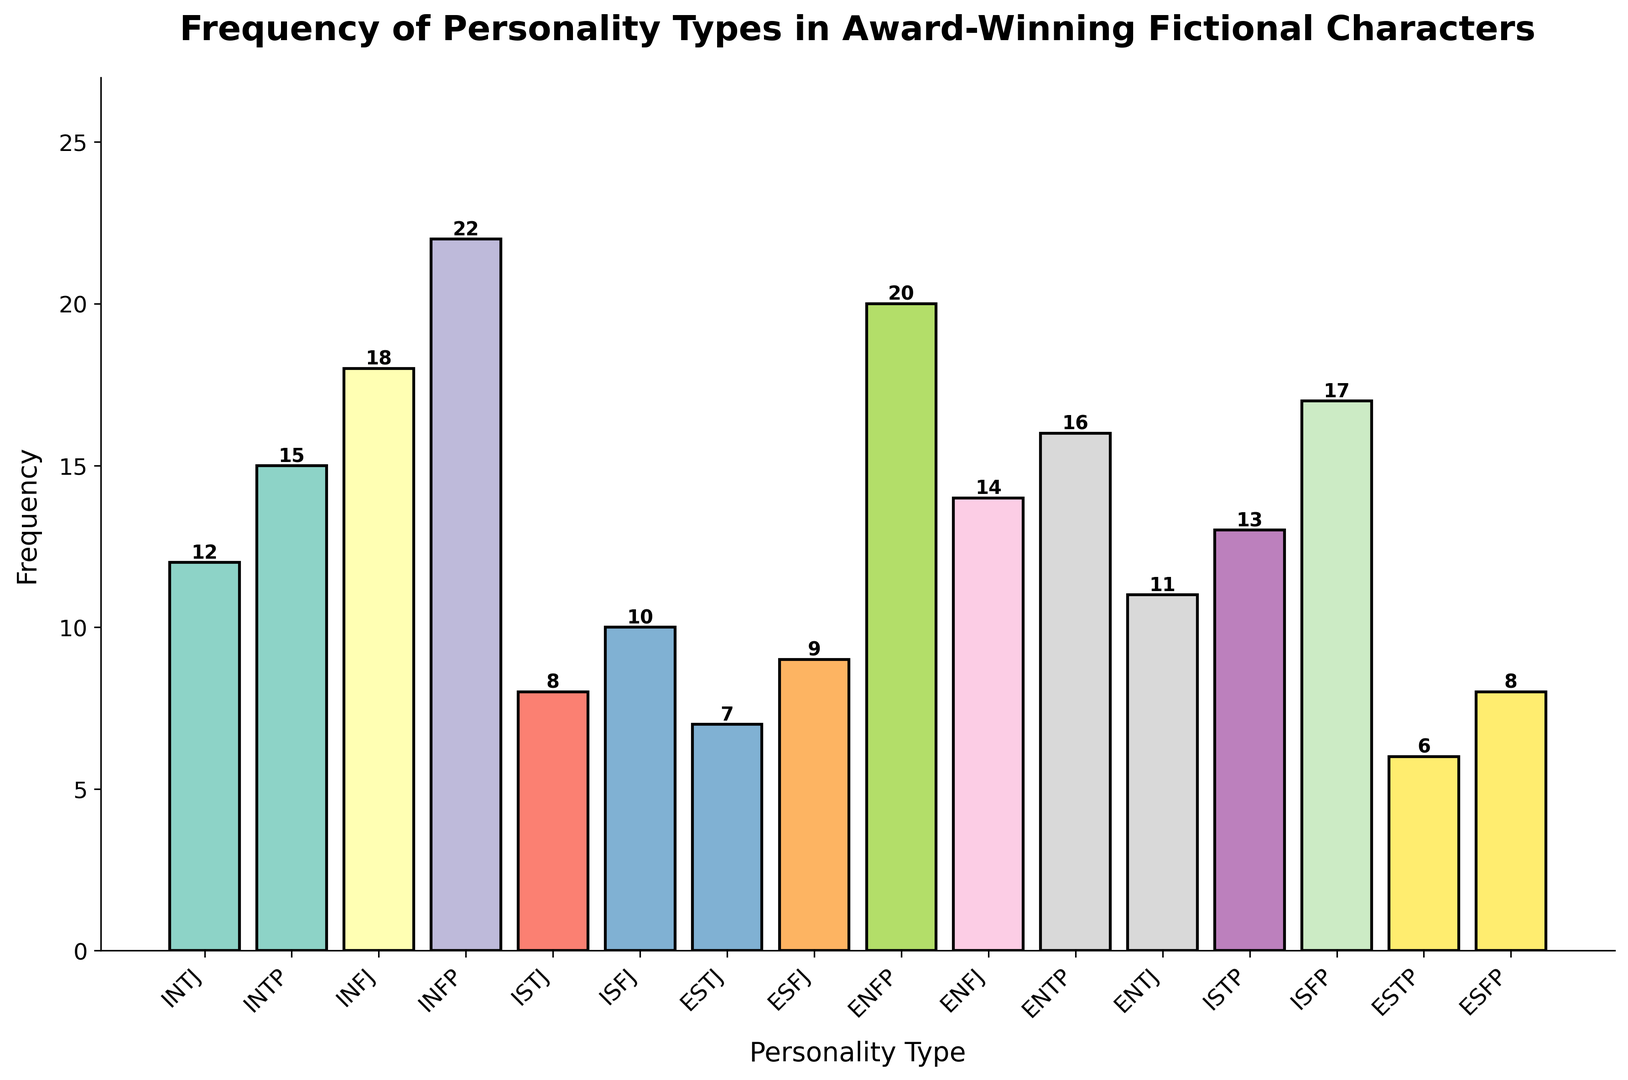What personality type has the highest frequency? We identify the highest bar in the histogram, which represents the INFP personality type with a frequency of 22.
Answer: INFP Which personality type has the lowest frequency? We look for the shortest bar in the histogram, which is ESTP with a frequency of 6.
Answer: ESTP What is the total frequency of INFJ and INFP personality types? Find the frequencies of INFJ and INFP (18 and 22 respectively) and sum them up (18 + 22 = 40).
Answer: 40 How many personality types have a frequency of 10 or more? Count the bars that have a frequency of 10 or more: INTP (15), INFJ (18), INFP (22), ISFJ (10), ENFP (20), ENFJ (14), ENTP (16), ENTJ (11), ISTP (13), ISFP (17). There are 10 personality types.
Answer: 10 Which personality type has a frequency closest to the average frequency? First, calculate the average frequency by summing all frequencies (210) and dividing by the number of personality types (16), which is 210 / 16 = 13.125. The closest frequency to 13.125 is that of ISTP, which is 13.
Answer: ISTP What is the frequency difference between the most and least frequent personality types? Subtract the frequency of the least frequent (ESTP, 6) from the most frequent (INFP, 22) to find the difference (22 - 6 = 16).
Answer: 16 How many personality types have frequencies between 10 and 20? Count the bars that fall between 10 and 20: INTP (15), INFJ (18), ISFJ (10), ENFP (20), ENFJ (14), ENTP (16), ENTJ (11), ISTP (13), ISFP (17), which total 9 bars.
Answer: 9 Which personality type has the third highest frequency? After INFP (22) and ENFP (20), the next highest frequency is INTP (15).
Answer: INTP 